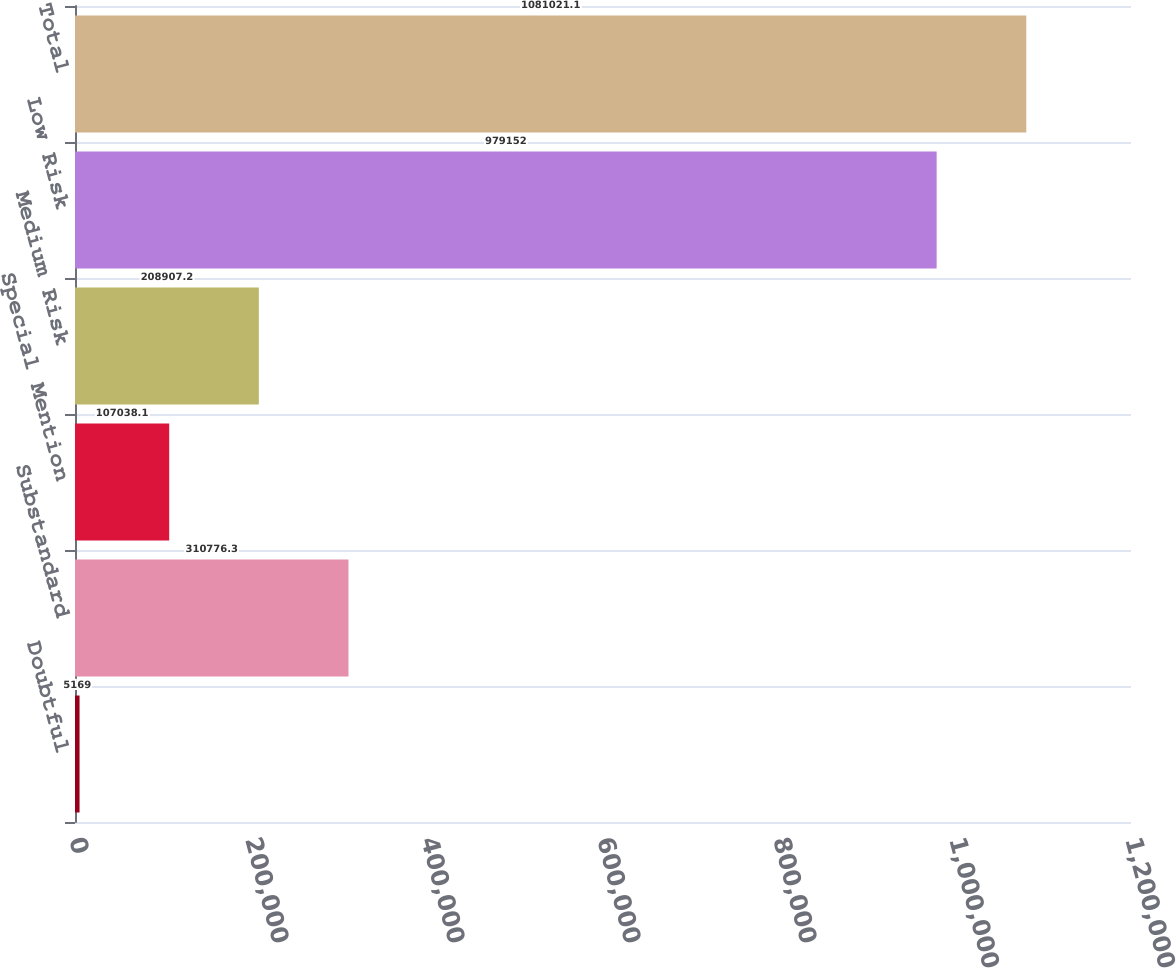<chart> <loc_0><loc_0><loc_500><loc_500><bar_chart><fcel>Doubtful<fcel>Substandard<fcel>Special Mention<fcel>Medium Risk<fcel>Low Risk<fcel>Total<nl><fcel>5169<fcel>310776<fcel>107038<fcel>208907<fcel>979152<fcel>1.08102e+06<nl></chart> 